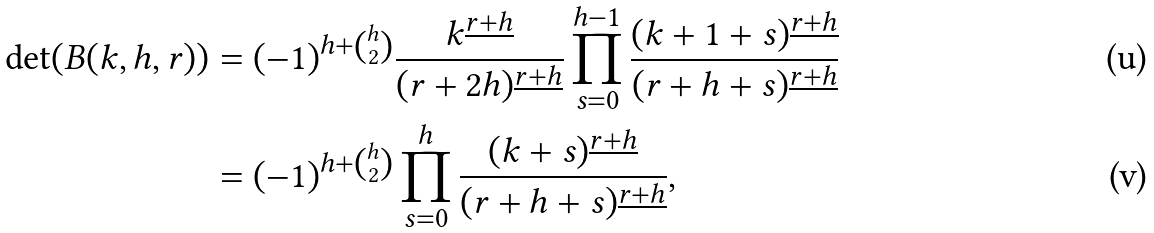<formula> <loc_0><loc_0><loc_500><loc_500>\det ( B ( k , h , r ) ) & = ( - 1 ) ^ { h + \binom { h } { 2 } } \frac { k ^ { \underline { r + h } } } { ( r + 2 h ) ^ { \underline { r + h } } } \prod _ { s = 0 } ^ { h - 1 } \frac { ( k + 1 + s ) ^ { \underline { r + h } } } { ( r + h + s ) ^ { \underline { r + h } } } \\ & = ( - 1 ) ^ { h + \binom { h } { 2 } } \prod _ { s = 0 } ^ { h } \frac { ( k + s ) ^ { \underline { r + h } } } { ( r + h + s ) ^ { \underline { r + h } } } ,</formula> 